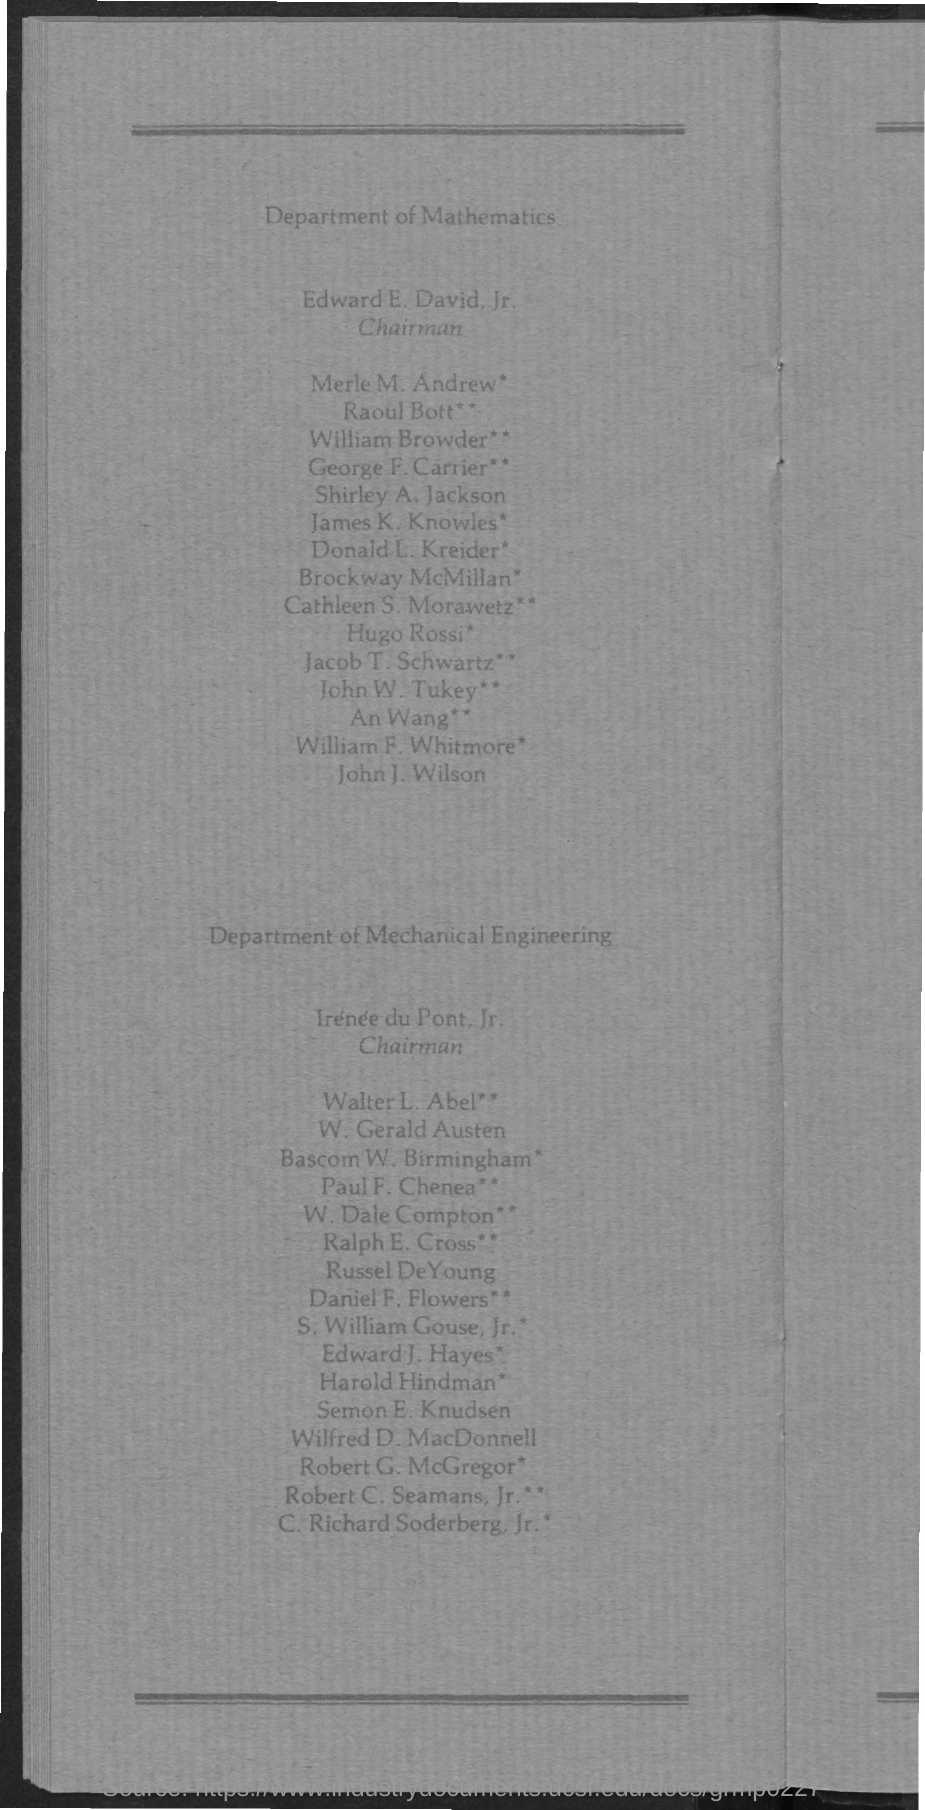Who is the Chairman for Department of Mathematics?
Offer a terse response. Edward E. David, Jr. 